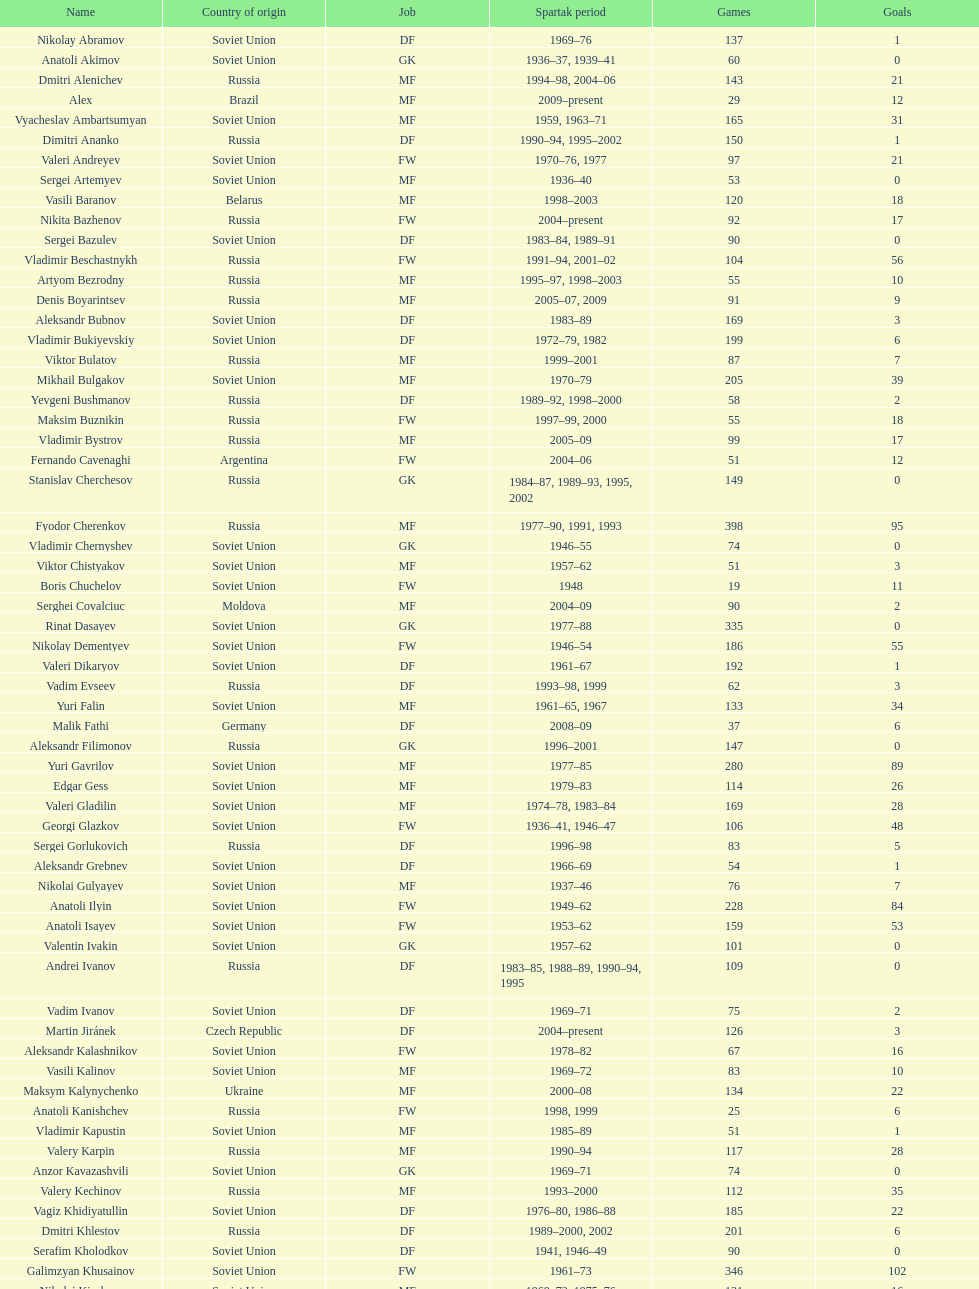Which player has the most appearances with the club? Fyodor Cherenkov. 